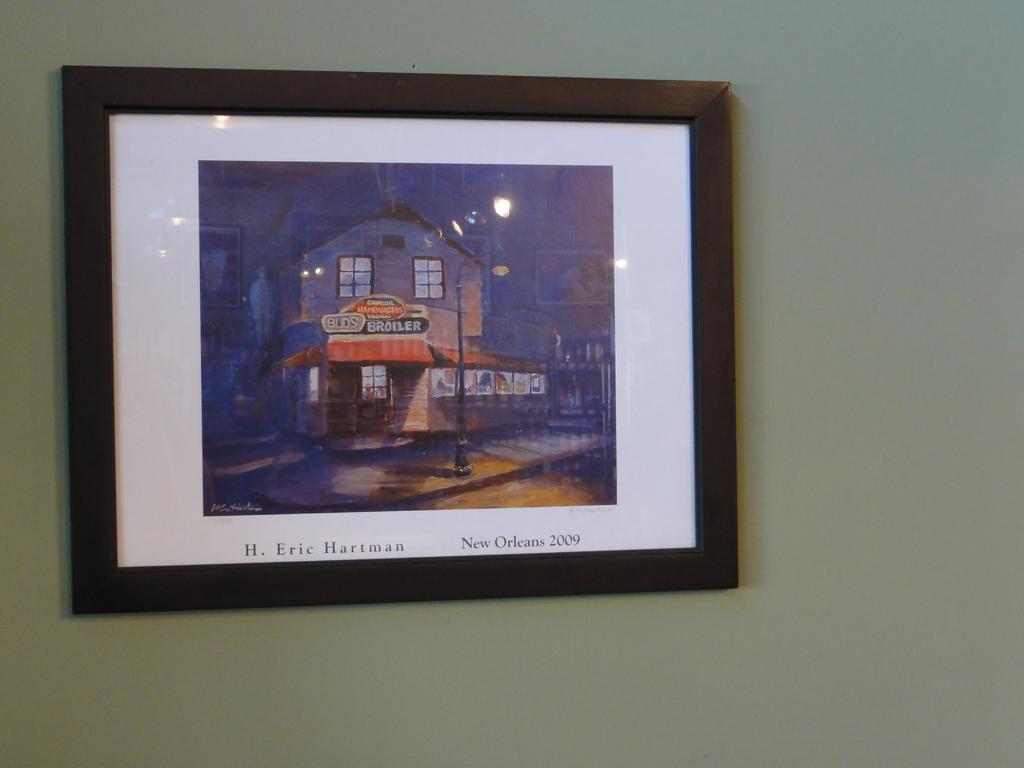<image>
Share a concise interpretation of the image provided. A framed work by H. Eric Hartman shows a building in New Orleans. 